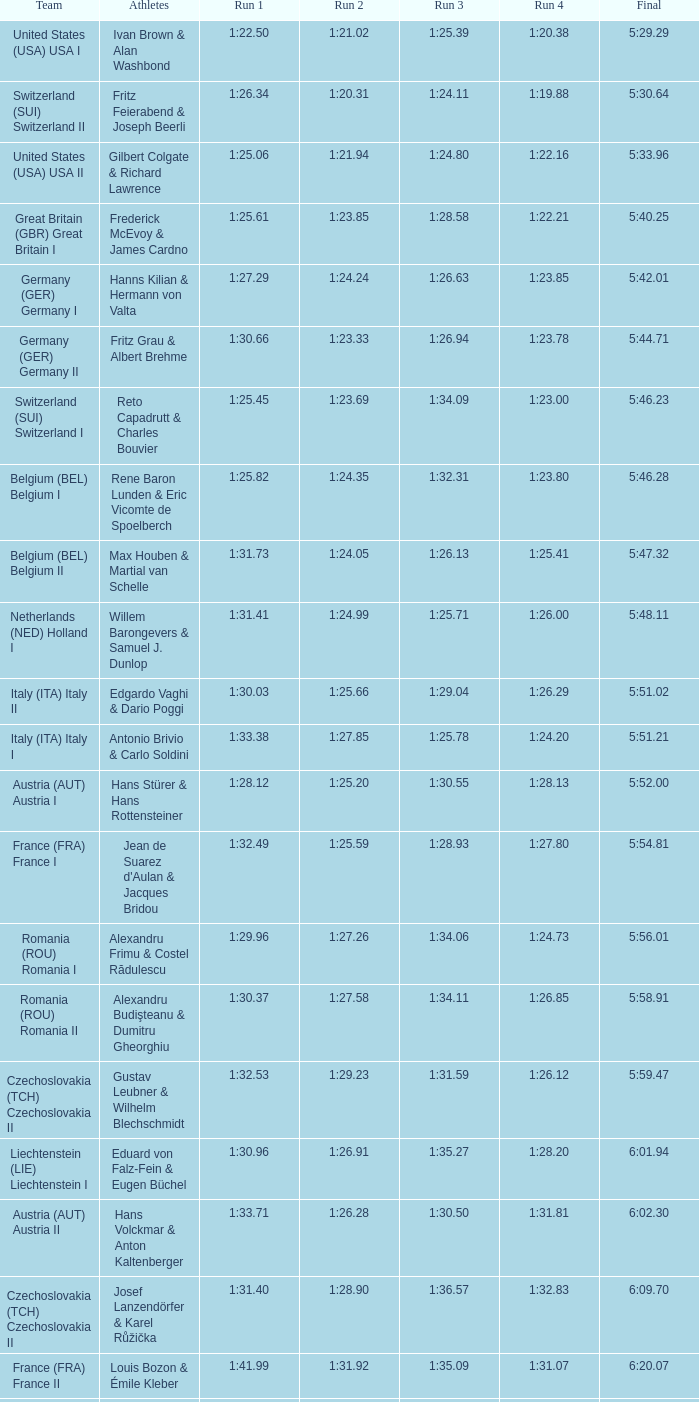Which Final has a Run 2 of 1:27.58? 5:58.91. 